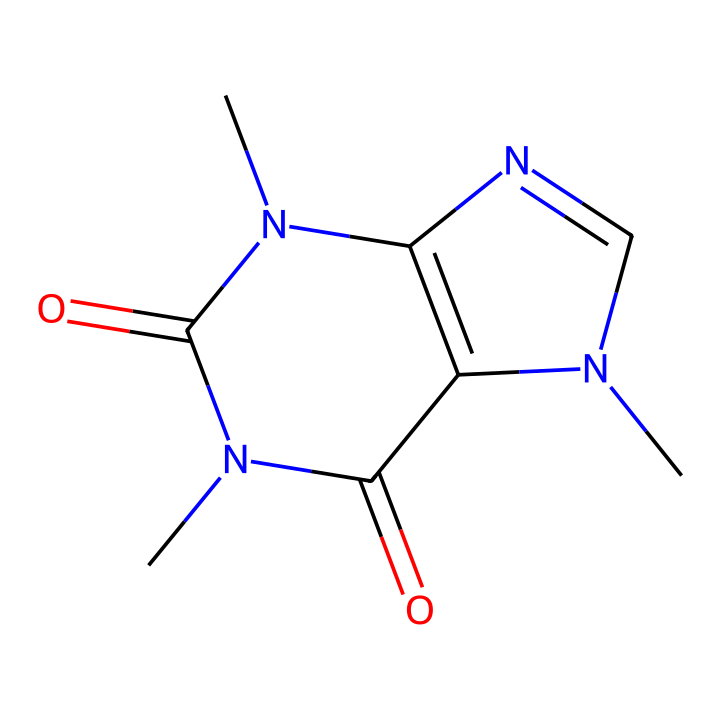What is the molecular formula of this compound? To determine the molecular formula, count the number of each type of atom in the chemical structure represented by the SMILES. The atoms include carbon (C), hydrogen (H), nitrogen (N), and oxygen (O), which gives C8H10N4O2.
Answer: C8H10N4O2 How many nitrogen atoms are present in the chemical structure? By examining the SMILES notation, we can see there are four nitrogen atoms (N) indicated in the structure.
Answer: 4 What type of chemical compound is represented? This molecule contains nitrogen and has a structure characteristic of alkaloids, which are primarily derived from plant sources such as coffee and tea where caffeine is found.
Answer: alkaloid What is the functional group present in caffeine? The presence of carbonyl groups (=O) indicates the functional groups related to amides (from the N and O connections), typical in caffeine's structure as it has functional significance.
Answer: amide What is the connectivity of atoms in the structure? In the SMILES, connectivity is shown with characters indicating rings (C1, C2) and branches, revealing that the molecule has a bicyclic structure indicating the bonding pattern between carbon and nitrogen atoms within these rings.
Answer: bicyclic What does the presence of oxygen indicate about caffeine? The presence of oxygen atoms in the chemical structure suggests that caffeine has polar characteristics, which can influence its solubility in water compared to purely hydrocarbon structures.
Answer: polar characteristics 